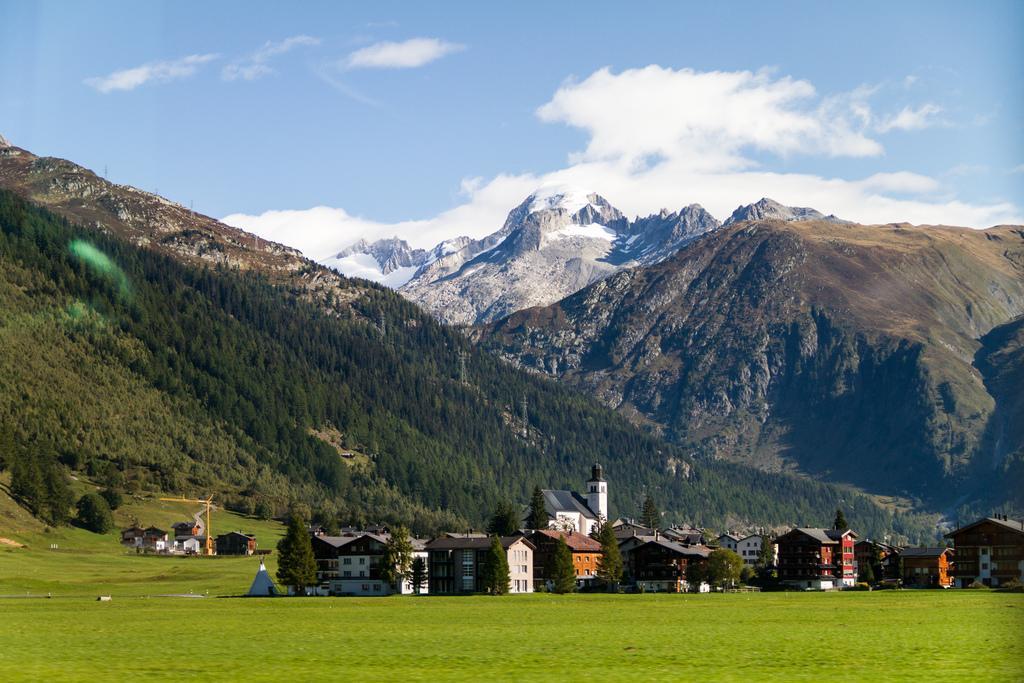Could you give a brief overview of what you see in this image? In this image I can see few buildings in brown and cream color. Background I can see few trees in green color, mountains and the sky is in blue and white color. 